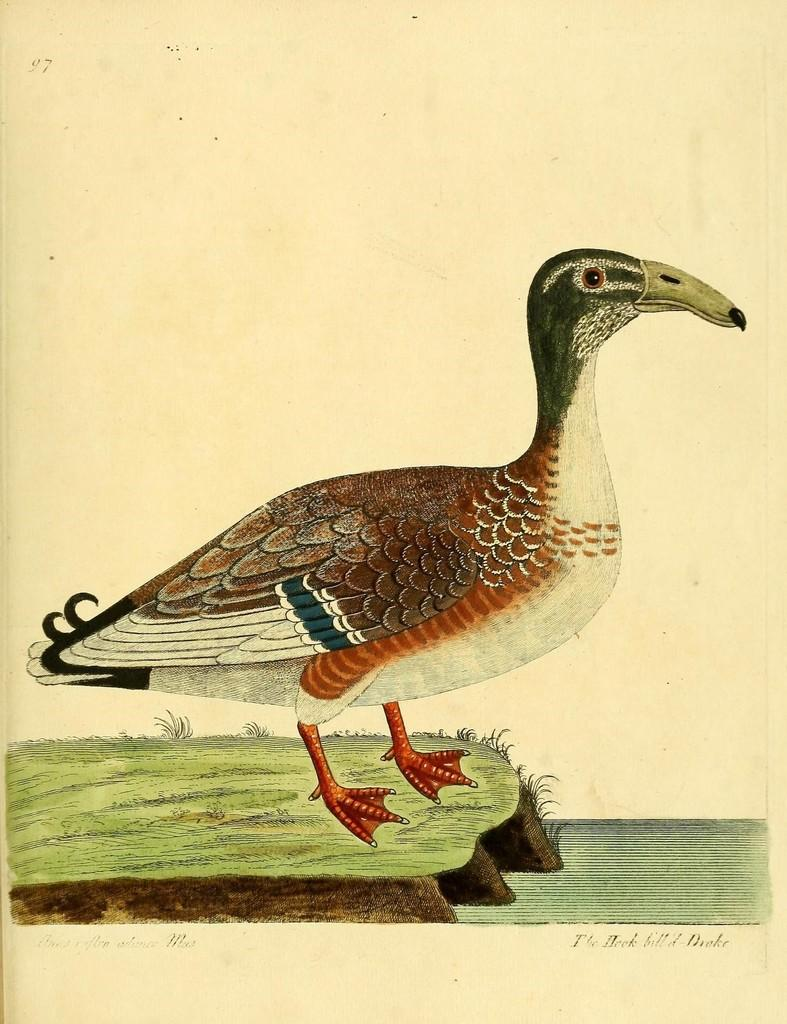What is the main subject of the image? The image contains an art piece. Can you describe the scene in the art piece? There is a bird standing on the grass in the image. Is there any text or writing in the image? Yes, there is text or writing at the bottom portion of the image. How much salt is being used in the image? There is no salt present in the image. What type of star can be seen in the image? There is no star present in the image. 